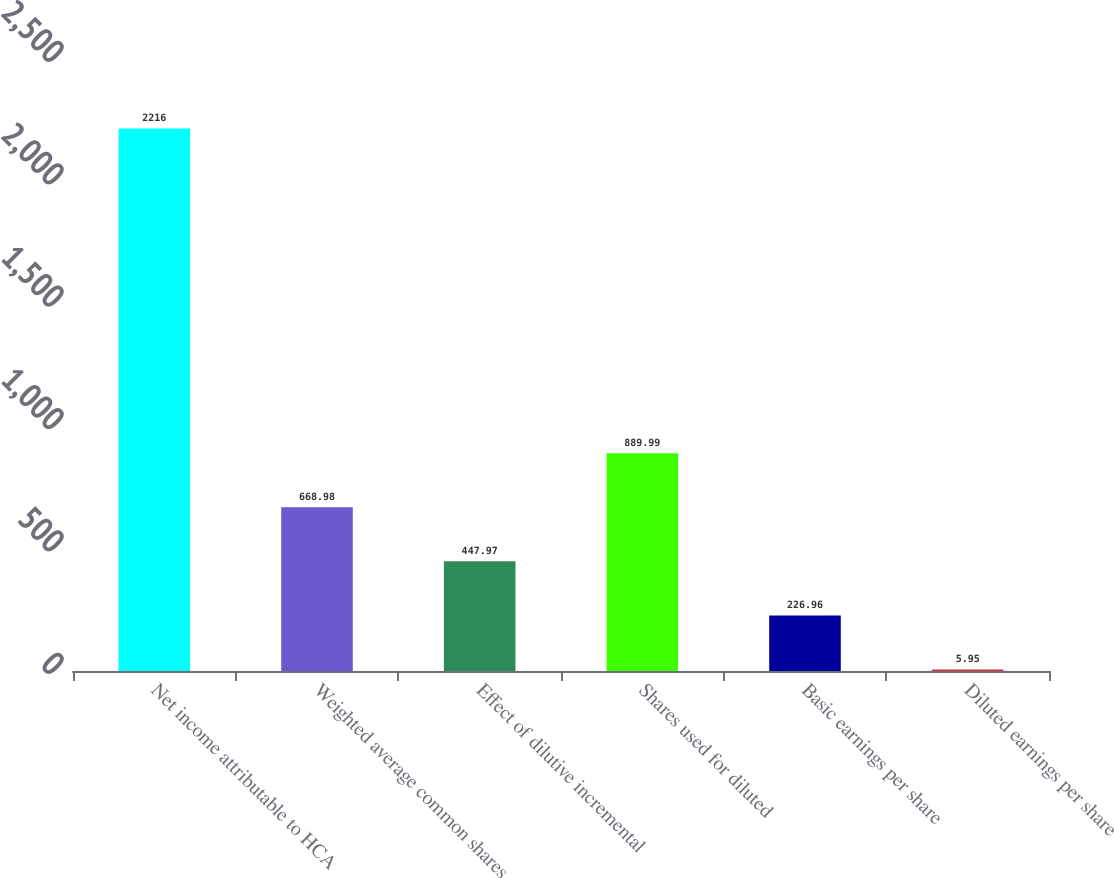Convert chart. <chart><loc_0><loc_0><loc_500><loc_500><bar_chart><fcel>Net income attributable to HCA<fcel>Weighted average common shares<fcel>Effect of dilutive incremental<fcel>Shares used for diluted<fcel>Basic earnings per share<fcel>Diluted earnings per share<nl><fcel>2216<fcel>668.98<fcel>447.97<fcel>889.99<fcel>226.96<fcel>5.95<nl></chart> 